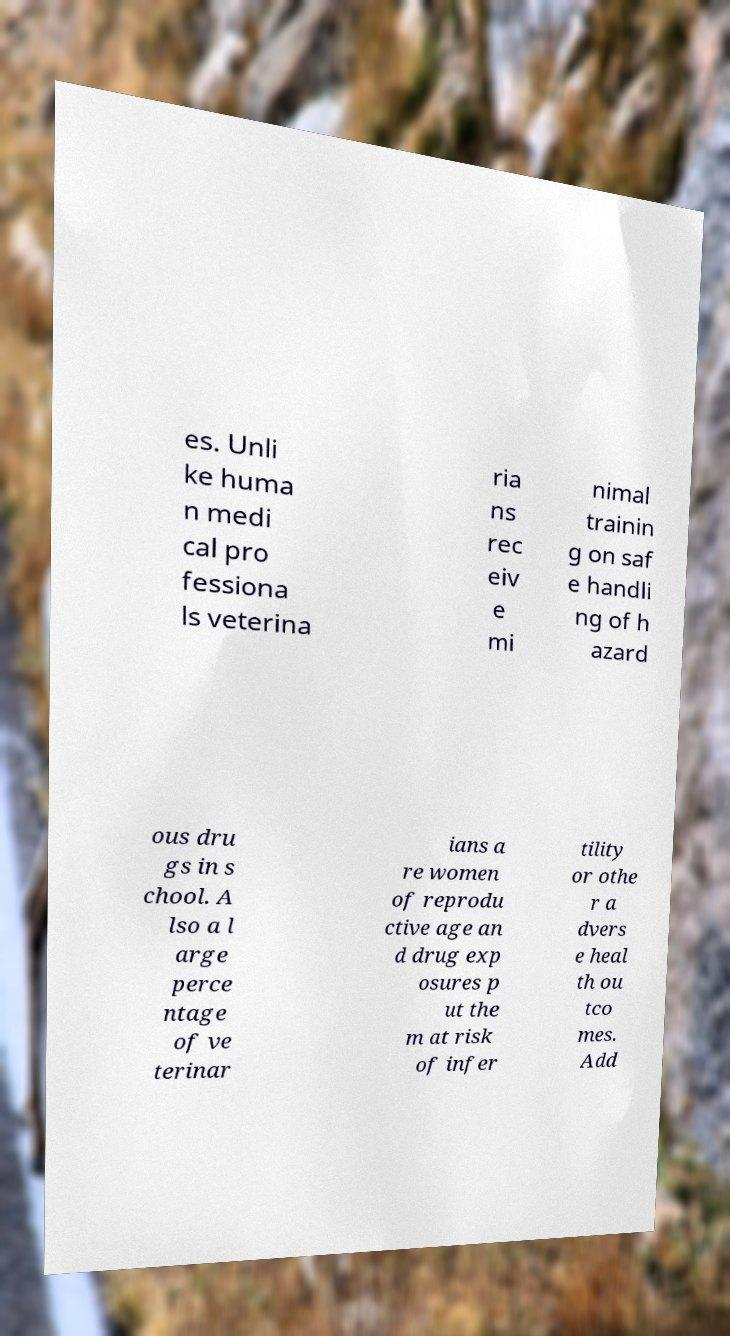What messages or text are displayed in this image? I need them in a readable, typed format. es. Unli ke huma n medi cal pro fessiona ls veterina ria ns rec eiv e mi nimal trainin g on saf e handli ng of h azard ous dru gs in s chool. A lso a l arge perce ntage of ve terinar ians a re women of reprodu ctive age an d drug exp osures p ut the m at risk of infer tility or othe r a dvers e heal th ou tco mes. Add 